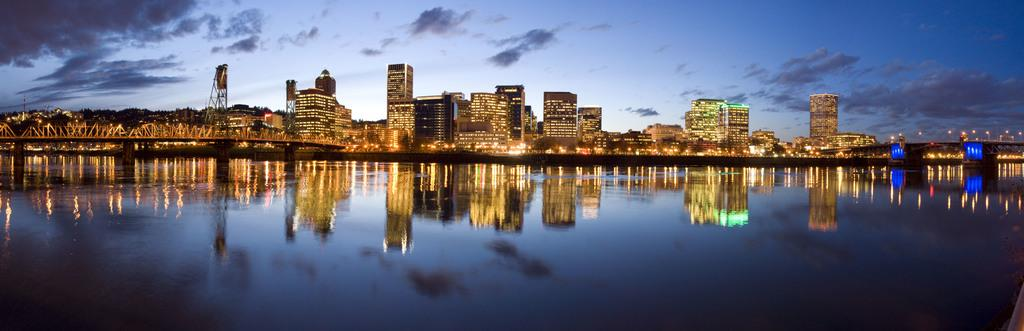What is the main feature of the image? The main feature of the image is water. What type of structures can be seen in the image? There are tower buildings in the image. Where is the bridge located in the image? The bridge is on the left side of the image. What can be seen illuminating the scene in the image? There are lights visible in the image. What is the condition of the sky in the background of the image? The sky is dark in the background, and clouds are present. Can you tell me how many women are working on the farm in the image? There is no farm or woman present in the image; it features water, tower buildings, a bridge, lights, and a dark sky with clouds. 